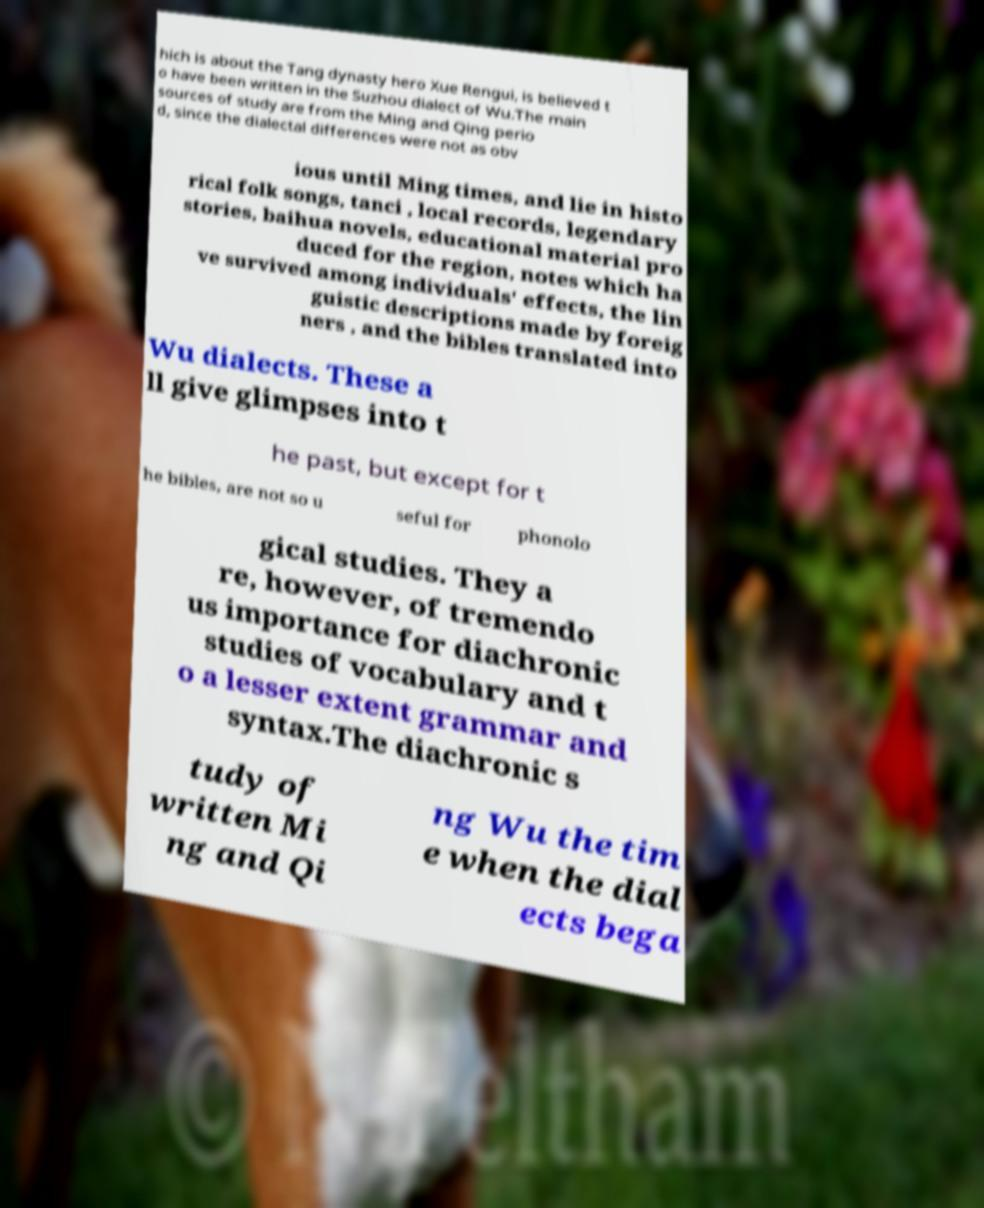Please read and relay the text visible in this image. What does it say? hich is about the Tang dynasty hero Xue Rengui, is believed t o have been written in the Suzhou dialect of Wu.The main sources of study are from the Ming and Qing perio d, since the dialectal differences were not as obv ious until Ming times, and lie in histo rical folk songs, tanci , local records, legendary stories, baihua novels, educational material pro duced for the region, notes which ha ve survived among individuals' effects, the lin guistic descriptions made by foreig ners , and the bibles translated into Wu dialects. These a ll give glimpses into t he past, but except for t he bibles, are not so u seful for phonolo gical studies. They a re, however, of tremendo us importance for diachronic studies of vocabulary and t o a lesser extent grammar and syntax.The diachronic s tudy of written Mi ng and Qi ng Wu the tim e when the dial ects bega 